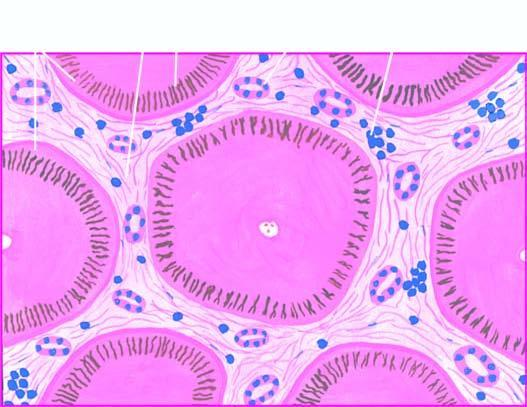do many of the hepatocytes contain elongated bile plugs?
Answer the question using a single word or phrase. Yes 